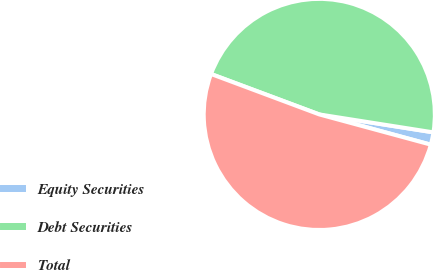Convert chart. <chart><loc_0><loc_0><loc_500><loc_500><pie_chart><fcel>Equity Securities<fcel>Debt Securities<fcel>Total<nl><fcel>1.73%<fcel>46.79%<fcel>51.47%<nl></chart> 